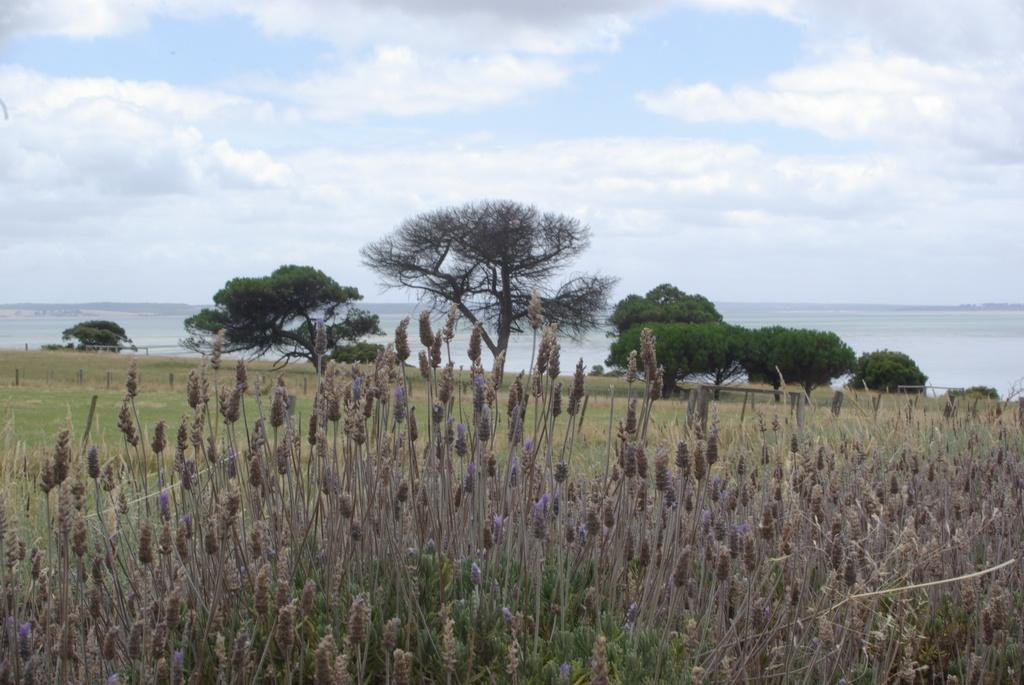What type of living organisms can be seen in the image? Plants can be seen in the image. What specific features do the plants have? The plants have branches and leaves. What else is visible in the image besides the plants? Water is visible in the image. What can be seen in the sky in the image? Clouds can be seen in the sky. What type of good-bye is being said by the plants in the image? There is no indication in the image that the plants are saying good-bye or engaging in any form of communication. 